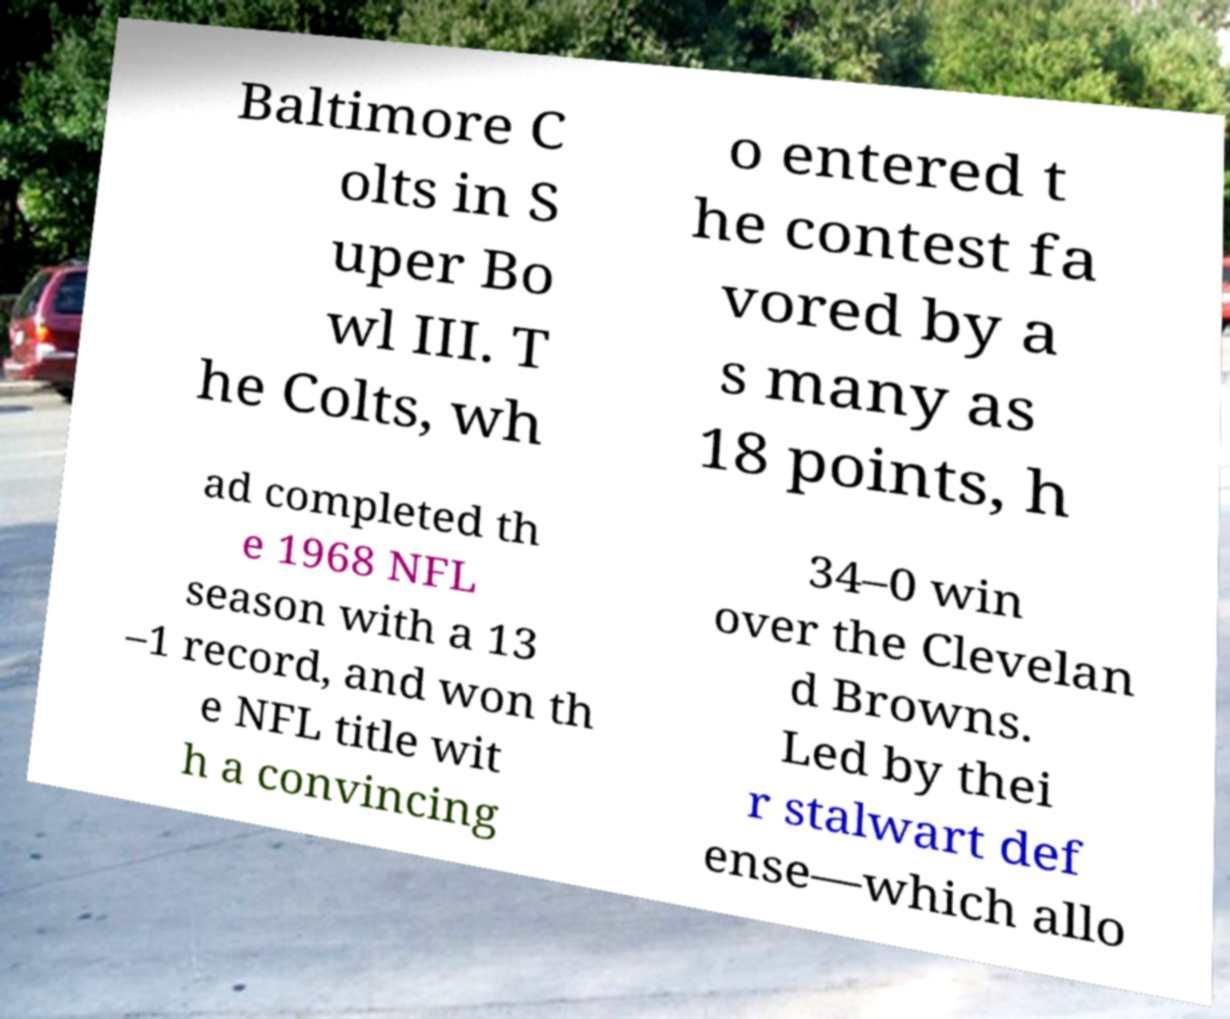I need the written content from this picture converted into text. Can you do that? Baltimore C olts in S uper Bo wl III. T he Colts, wh o entered t he contest fa vored by a s many as 18 points, h ad completed th e 1968 NFL season with a 13 –1 record, and won th e NFL title wit h a convincing 34–0 win over the Clevelan d Browns. Led by thei r stalwart def ense—which allo 